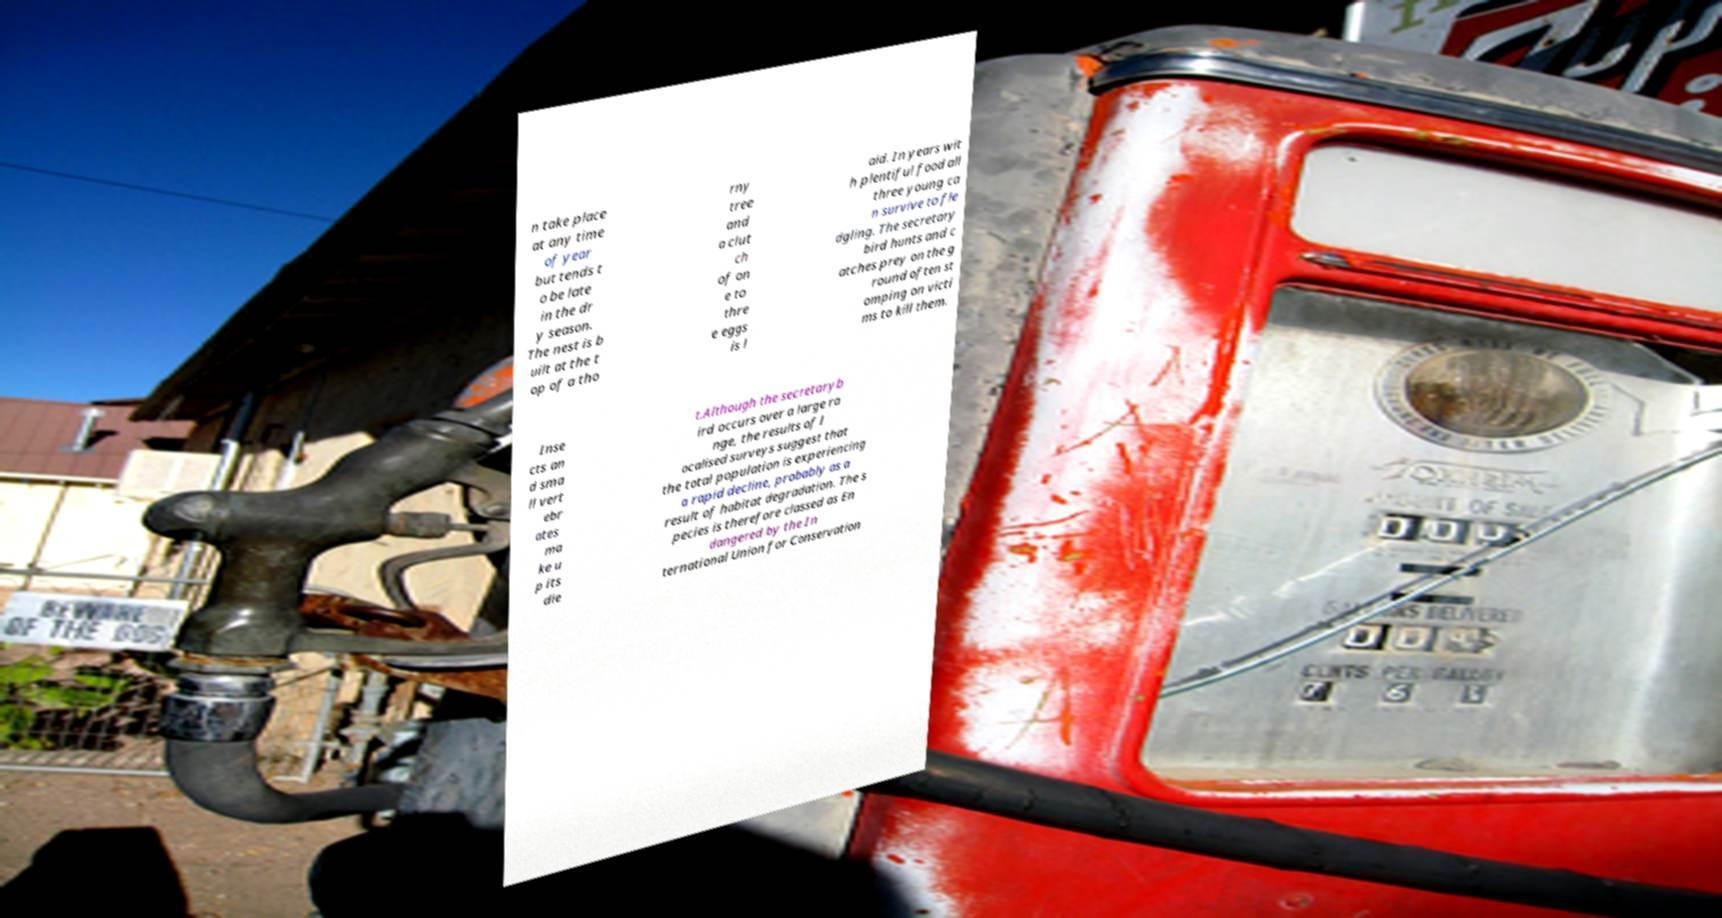There's text embedded in this image that I need extracted. Can you transcribe it verbatim? n take place at any time of year but tends t o be late in the dr y season. The nest is b uilt at the t op of a tho rny tree and a clut ch of on e to thre e eggs is l aid. In years wit h plentiful food all three young ca n survive to fle dgling. The secretary bird hunts and c atches prey on the g round often st omping on victi ms to kill them. Inse cts an d sma ll vert ebr ates ma ke u p its die t.Although the secretaryb ird occurs over a large ra nge, the results of l ocalised surveys suggest that the total population is experiencing a rapid decline, probably as a result of habitat degradation. The s pecies is therefore classed as En dangered by the In ternational Union for Conservation 